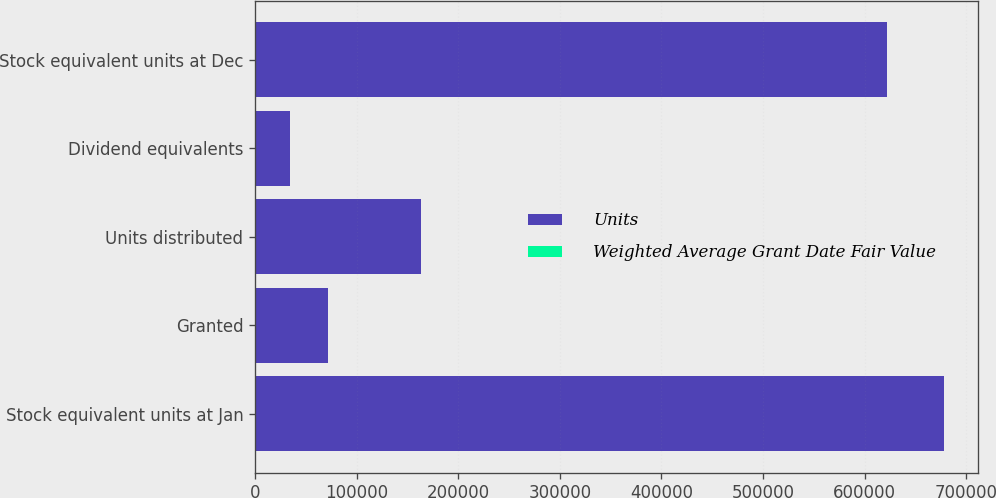Convert chart to OTSL. <chart><loc_0><loc_0><loc_500><loc_500><stacked_bar_chart><ecel><fcel>Stock equivalent units at Jan<fcel>Granted<fcel>Units distributed<fcel>Dividend equivalents<fcel>Stock equivalent units at Dec<nl><fcel>Units<fcel>677738<fcel>72185<fcel>162923<fcel>34803<fcel>621803<nl><fcel>Weighted Average Grant Date Fair Value<fcel>19.81<fcel>17.87<fcel>19.74<fcel>18.76<fcel>19.5<nl></chart> 